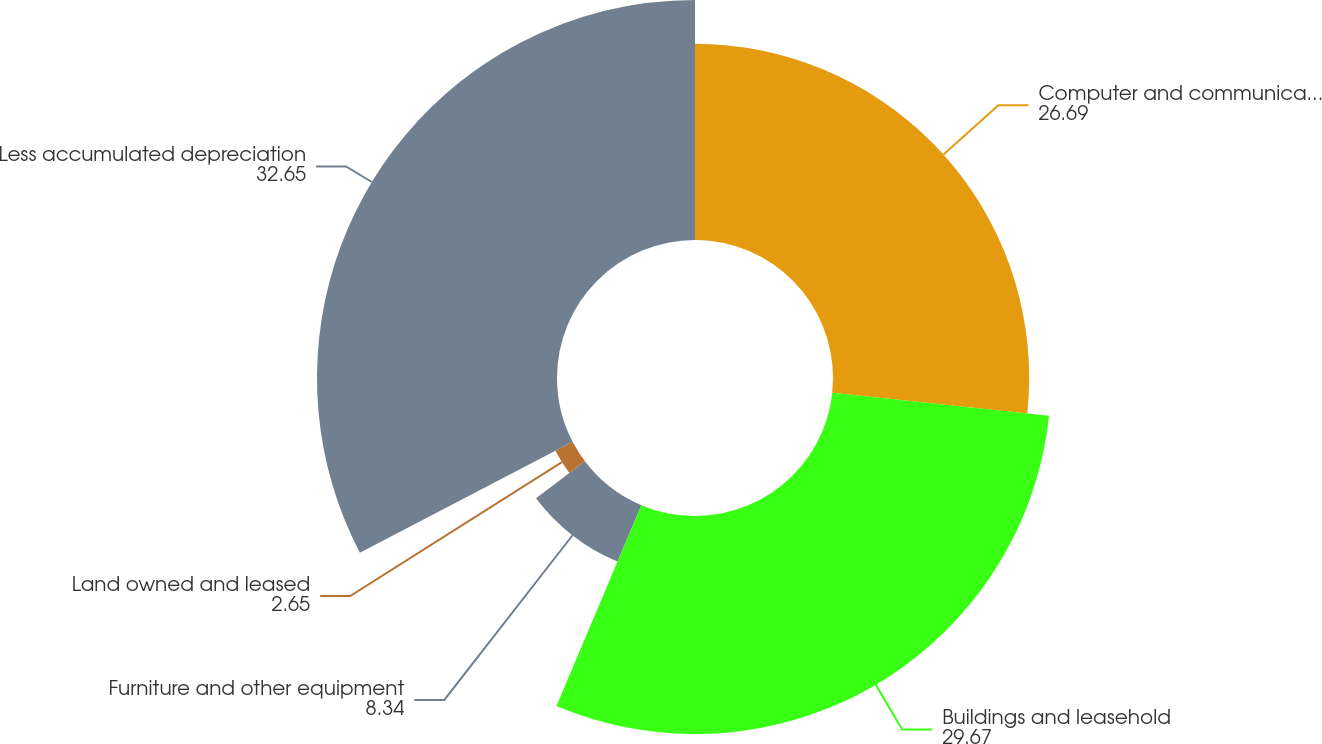<chart> <loc_0><loc_0><loc_500><loc_500><pie_chart><fcel>Computer and communications<fcel>Buildings and leasehold<fcel>Furniture and other equipment<fcel>Land owned and leased<fcel>Less accumulated depreciation<nl><fcel>26.69%<fcel>29.67%<fcel>8.34%<fcel>2.65%<fcel>32.65%<nl></chart> 